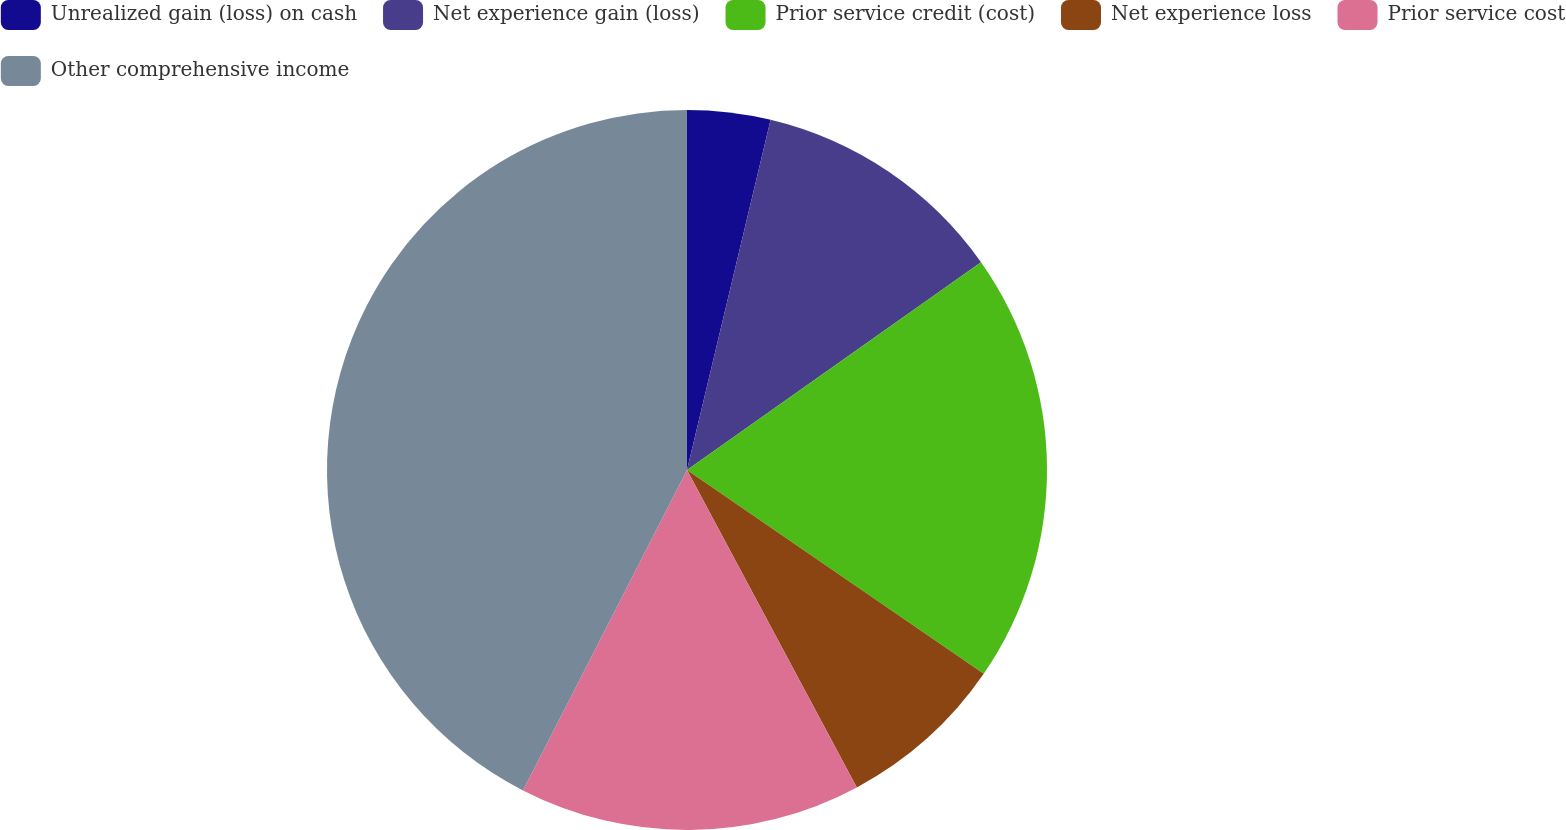Convert chart to OTSL. <chart><loc_0><loc_0><loc_500><loc_500><pie_chart><fcel>Unrealized gain (loss) on cash<fcel>Net experience gain (loss)<fcel>Prior service credit (cost)<fcel>Net experience loss<fcel>Prior service cost<fcel>Other comprehensive income<nl><fcel>3.73%<fcel>11.48%<fcel>19.37%<fcel>7.6%<fcel>15.35%<fcel>42.47%<nl></chart> 